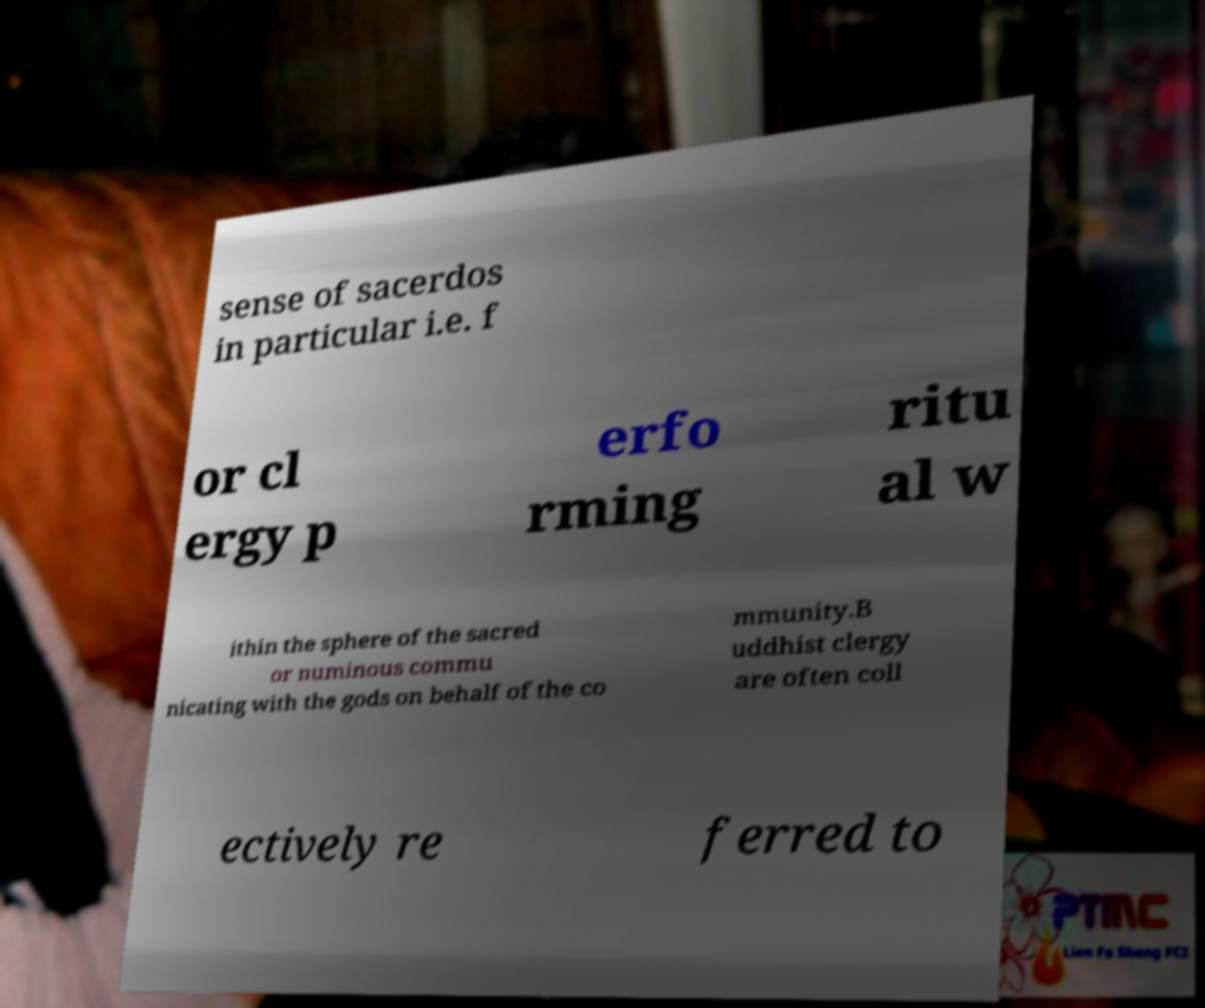Can you accurately transcribe the text from the provided image for me? sense of sacerdos in particular i.e. f or cl ergy p erfo rming ritu al w ithin the sphere of the sacred or numinous commu nicating with the gods on behalf of the co mmunity.B uddhist clergy are often coll ectively re ferred to 